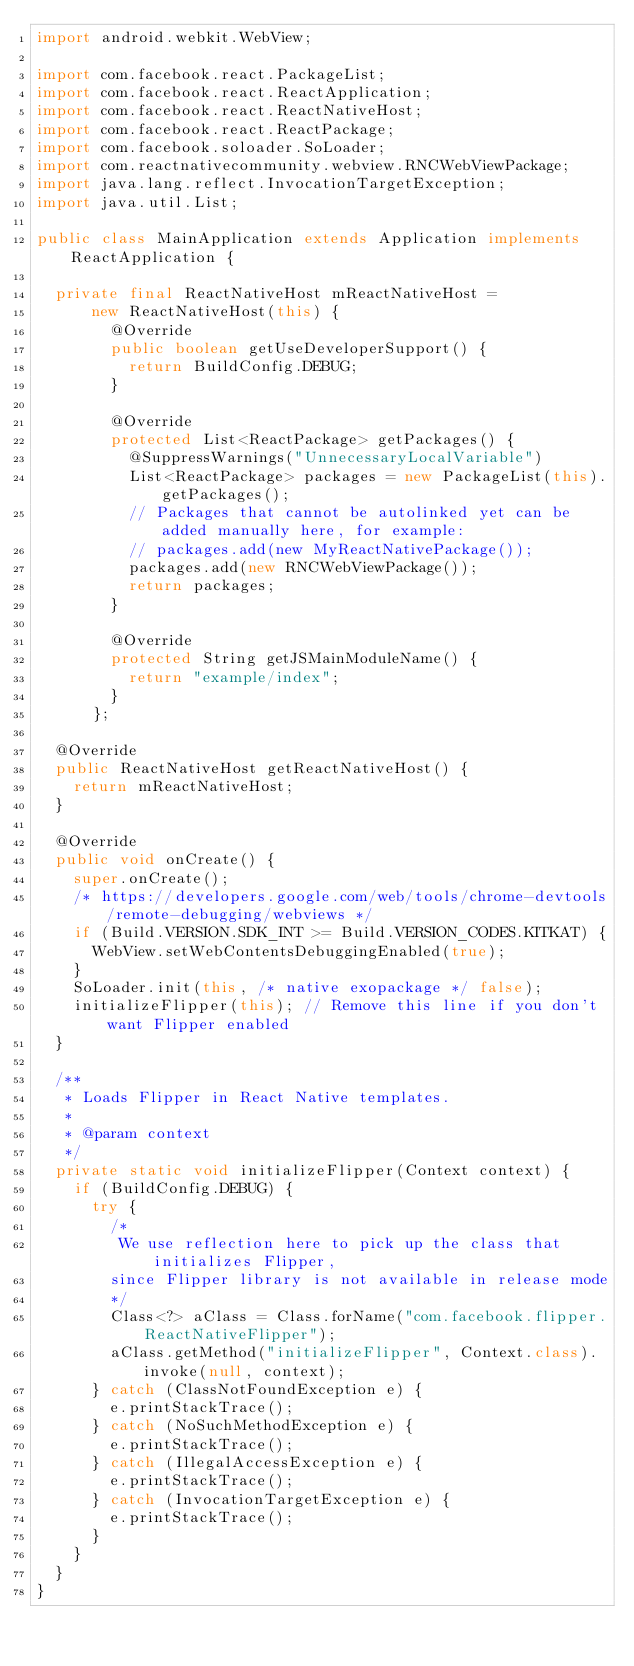<code> <loc_0><loc_0><loc_500><loc_500><_Java_>import android.webkit.WebView;

import com.facebook.react.PackageList;
import com.facebook.react.ReactApplication;
import com.facebook.react.ReactNativeHost;
import com.facebook.react.ReactPackage;
import com.facebook.soloader.SoLoader;
import com.reactnativecommunity.webview.RNCWebViewPackage;
import java.lang.reflect.InvocationTargetException;
import java.util.List;

public class MainApplication extends Application implements ReactApplication {

  private final ReactNativeHost mReactNativeHost =
      new ReactNativeHost(this) {
        @Override
        public boolean getUseDeveloperSupport() {
          return BuildConfig.DEBUG;
        }

        @Override
        protected List<ReactPackage> getPackages() {
          @SuppressWarnings("UnnecessaryLocalVariable")
          List<ReactPackage> packages = new PackageList(this).getPackages();
          // Packages that cannot be autolinked yet can be added manually here, for example:
          // packages.add(new MyReactNativePackage());
          packages.add(new RNCWebViewPackage());
          return packages;
        }

        @Override
        protected String getJSMainModuleName() {
          return "example/index";
        }
      };

  @Override
  public ReactNativeHost getReactNativeHost() {
    return mReactNativeHost;
  }

  @Override
  public void onCreate() {
    super.onCreate();
    /* https://developers.google.com/web/tools/chrome-devtools/remote-debugging/webviews */
    if (Build.VERSION.SDK_INT >= Build.VERSION_CODES.KITKAT) {
      WebView.setWebContentsDebuggingEnabled(true);
    }
    SoLoader.init(this, /* native exopackage */ false);
    initializeFlipper(this); // Remove this line if you don't want Flipper enabled
  }

  /**
   * Loads Flipper in React Native templates.
   *
   * @param context
   */
  private static void initializeFlipper(Context context) {
    if (BuildConfig.DEBUG) {
      try {
        /*
         We use reflection here to pick up the class that initializes Flipper,
        since Flipper library is not available in release mode
        */
        Class<?> aClass = Class.forName("com.facebook.flipper.ReactNativeFlipper");
        aClass.getMethod("initializeFlipper", Context.class).invoke(null, context);
      } catch (ClassNotFoundException e) {
        e.printStackTrace();
      } catch (NoSuchMethodException e) {
        e.printStackTrace();
      } catch (IllegalAccessException e) {
        e.printStackTrace();
      } catch (InvocationTargetException e) {
        e.printStackTrace();
      }
    }
  }
}
</code> 